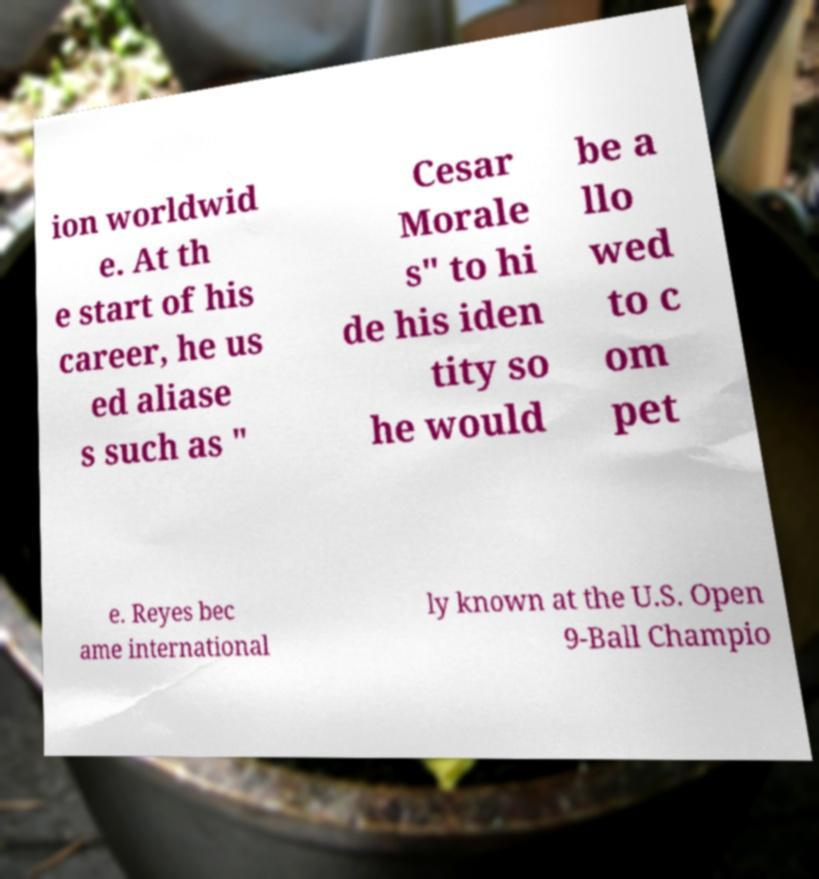Please read and relay the text visible in this image. What does it say? ion worldwid e. At th e start of his career, he us ed aliase s such as " Cesar Morale s" to hi de his iden tity so he would be a llo wed to c om pet e. Reyes bec ame international ly known at the U.S. Open 9-Ball Champio 